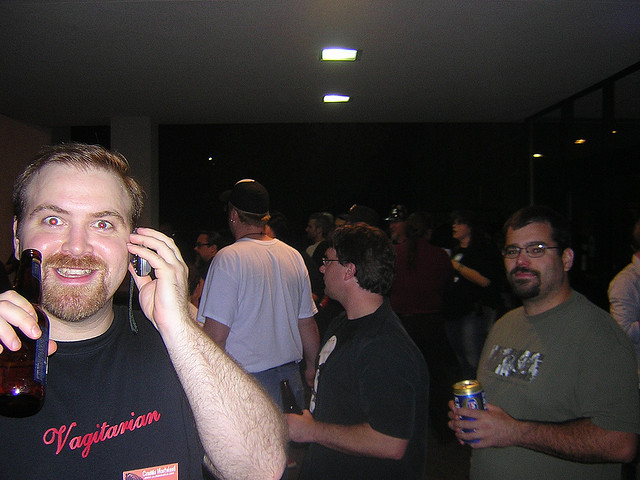Please transcribe the text information in this image. Vagitarian 